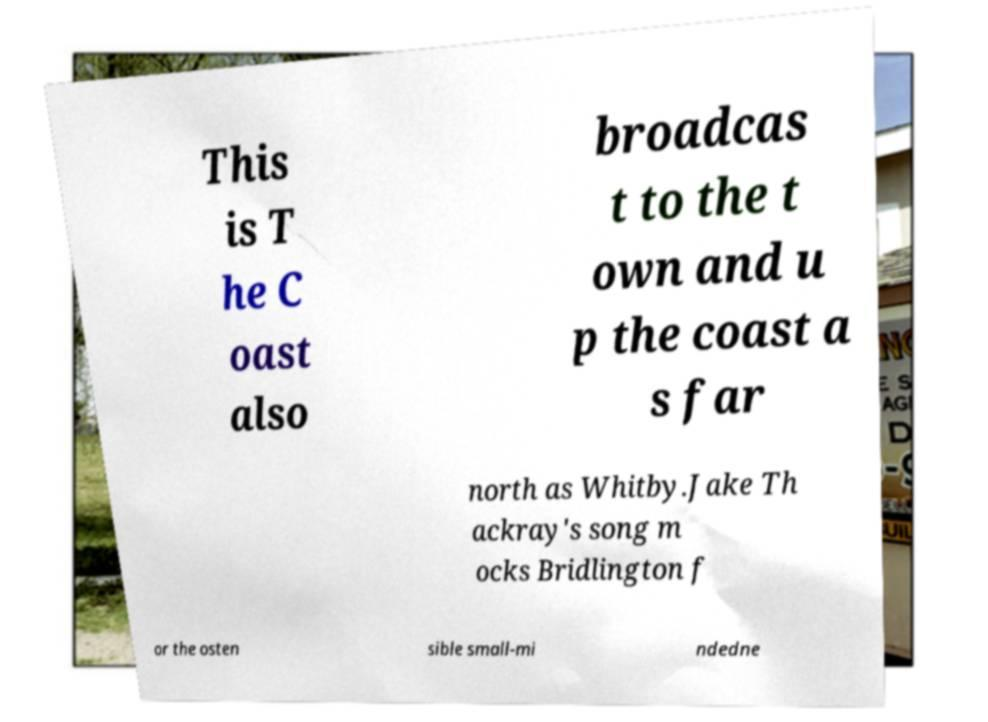Please identify and transcribe the text found in this image. This is T he C oast also broadcas t to the t own and u p the coast a s far north as Whitby.Jake Th ackray's song m ocks Bridlington f or the osten sible small-mi ndedne 